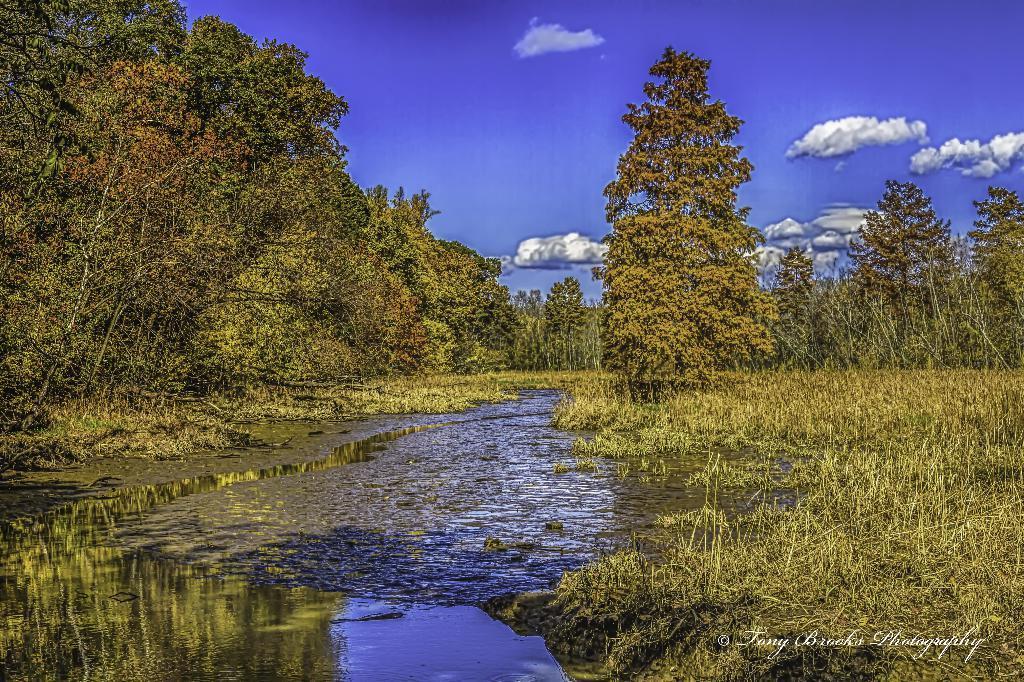How would you summarize this image in a sentence or two? In this picture there is water and there are few trees on either sides of it and the sky is a bit cloudy. 